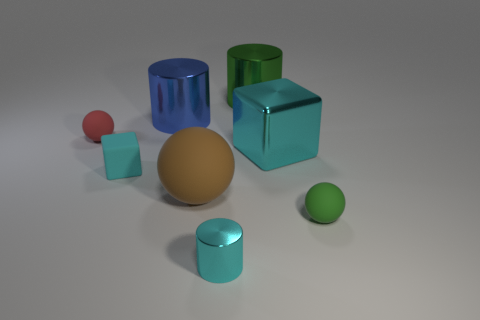There is a cylinder in front of the small matte ball that is to the left of the small rubber thing that is to the right of the small cyan metal thing; what is its material?
Your answer should be very brief. Metal. Are there the same number of big green metallic objects that are to the left of the large green shiny cylinder and big matte things?
Provide a short and direct response. No. Is the material of the cube that is on the left side of the big green thing the same as the green thing that is in front of the blue thing?
Offer a very short reply. Yes. How many things are either large gray shiny cylinders or cyan objects in front of the green ball?
Give a very brief answer. 1. Is there a cyan object of the same shape as the large blue metal thing?
Your response must be concise. Yes. What size is the green thing behind the red object in front of the large cylinder on the right side of the big blue thing?
Give a very brief answer. Large. Are there the same number of large blue shiny cylinders that are in front of the matte cube and green metal things behind the large green cylinder?
Provide a succinct answer. Yes. What size is the green cylinder that is made of the same material as the large blue cylinder?
Offer a very short reply. Large. What color is the small matte cube?
Provide a succinct answer. Cyan. How many rubber objects have the same color as the metallic block?
Offer a terse response. 1. 